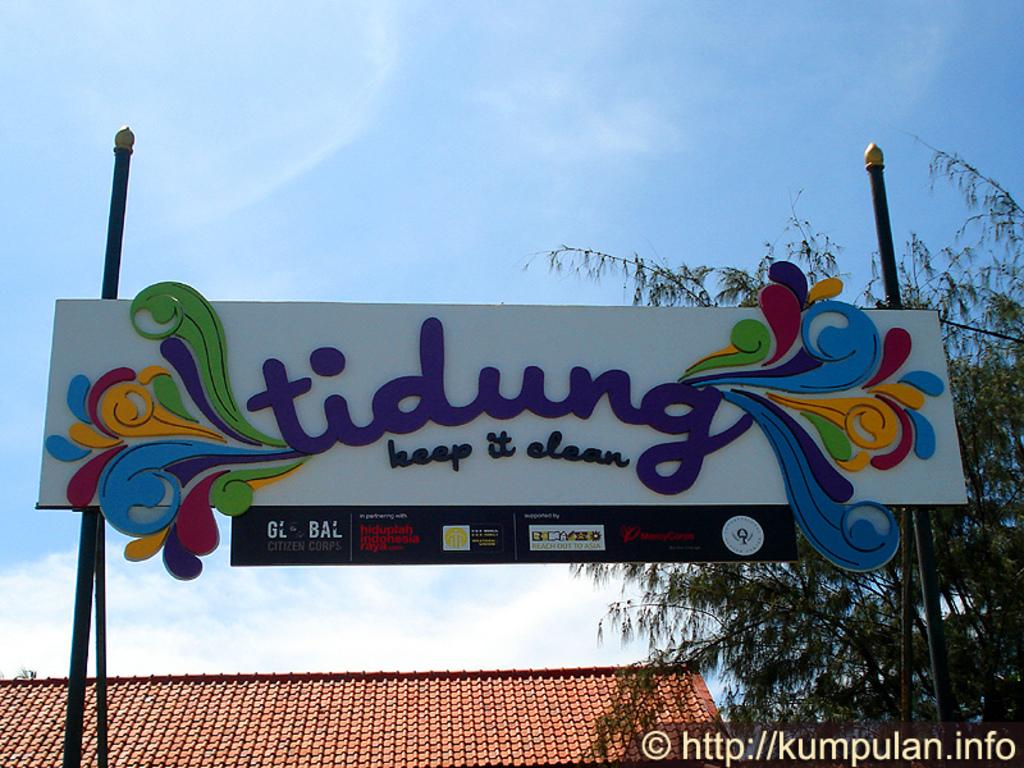<image>
Create a compact narrative representing the image presented. A sign encouraging people to keep things clean 